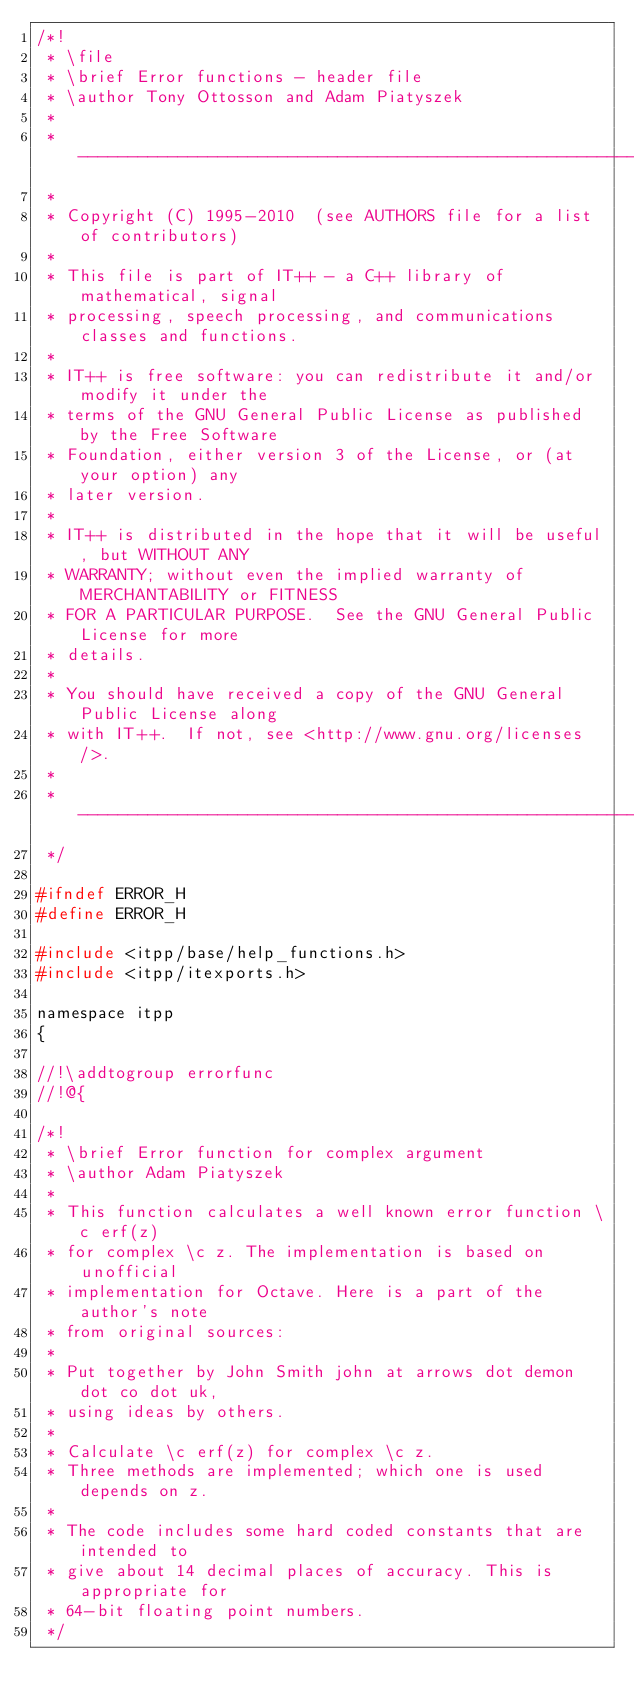Convert code to text. <code><loc_0><loc_0><loc_500><loc_500><_C_>/*!
 * \file
 * \brief Error functions - header file
 * \author Tony Ottosson and Adam Piatyszek
 *
 * -------------------------------------------------------------------------
 *
 * Copyright (C) 1995-2010  (see AUTHORS file for a list of contributors)
 *
 * This file is part of IT++ - a C++ library of mathematical, signal
 * processing, speech processing, and communications classes and functions.
 *
 * IT++ is free software: you can redistribute it and/or modify it under the
 * terms of the GNU General Public License as published by the Free Software
 * Foundation, either version 3 of the License, or (at your option) any
 * later version.
 *
 * IT++ is distributed in the hope that it will be useful, but WITHOUT ANY
 * WARRANTY; without even the implied warranty of MERCHANTABILITY or FITNESS
 * FOR A PARTICULAR PURPOSE.  See the GNU General Public License for more
 * details.
 *
 * You should have received a copy of the GNU General Public License along
 * with IT++.  If not, see <http://www.gnu.org/licenses/>.
 *
 * -------------------------------------------------------------------------
 */

#ifndef ERROR_H
#define ERROR_H

#include <itpp/base/help_functions.h>
#include <itpp/itexports.h>

namespace itpp
{

//!\addtogroup errorfunc
//!@{

/*!
 * \brief Error function for complex argument
 * \author Adam Piatyszek
 *
 * This function calculates a well known error function \c erf(z)
 * for complex \c z. The implementation is based on unofficial
 * implementation for Octave. Here is a part of the author's note
 * from original sources:
 *
 * Put together by John Smith john at arrows dot demon dot co dot uk,
 * using ideas by others.
 *
 * Calculate \c erf(z) for complex \c z.
 * Three methods are implemented; which one is used depends on z.
 *
 * The code includes some hard coded constants that are intended to
 * give about 14 decimal places of accuracy. This is appropriate for
 * 64-bit floating point numbers.
 */</code> 